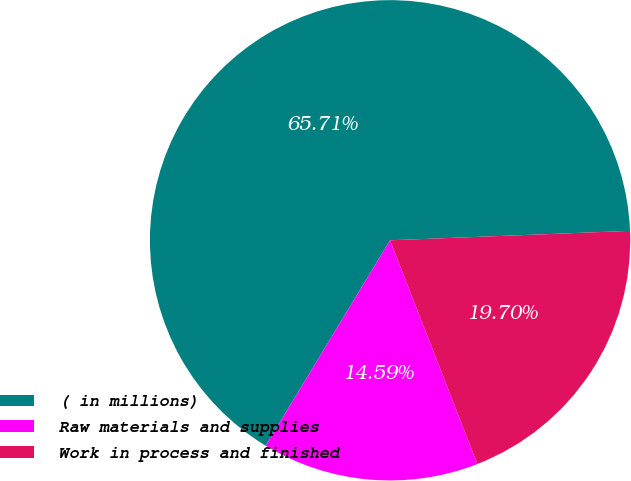Convert chart to OTSL. <chart><loc_0><loc_0><loc_500><loc_500><pie_chart><fcel>( in millions)<fcel>Raw materials and supplies<fcel>Work in process and finished<nl><fcel>65.7%<fcel>14.59%<fcel>19.7%<nl></chart> 